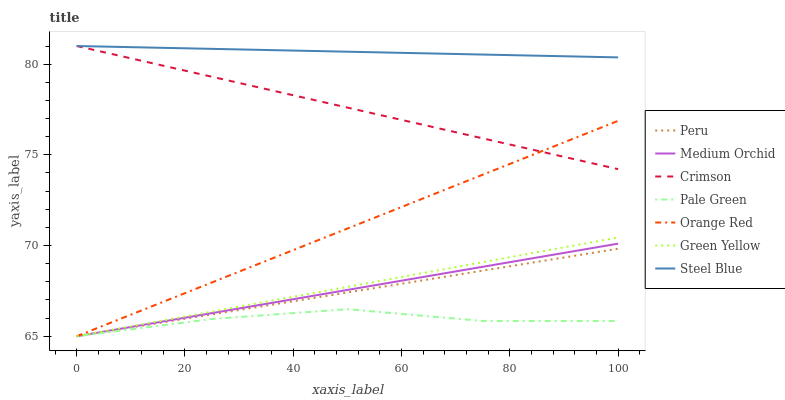Does Pale Green have the minimum area under the curve?
Answer yes or no. Yes. Does Steel Blue have the maximum area under the curve?
Answer yes or no. Yes. Does Steel Blue have the minimum area under the curve?
Answer yes or no. No. Does Pale Green have the maximum area under the curve?
Answer yes or no. No. Is Peru the smoothest?
Answer yes or no. Yes. Is Pale Green the roughest?
Answer yes or no. Yes. Is Steel Blue the smoothest?
Answer yes or no. No. Is Steel Blue the roughest?
Answer yes or no. No. Does Steel Blue have the lowest value?
Answer yes or no. No. Does Crimson have the highest value?
Answer yes or no. Yes. Does Pale Green have the highest value?
Answer yes or no. No. Is Medium Orchid less than Crimson?
Answer yes or no. Yes. Is Steel Blue greater than Peru?
Answer yes or no. Yes. Does Peru intersect Pale Green?
Answer yes or no. Yes. Is Peru less than Pale Green?
Answer yes or no. No. Is Peru greater than Pale Green?
Answer yes or no. No. Does Medium Orchid intersect Crimson?
Answer yes or no. No. 